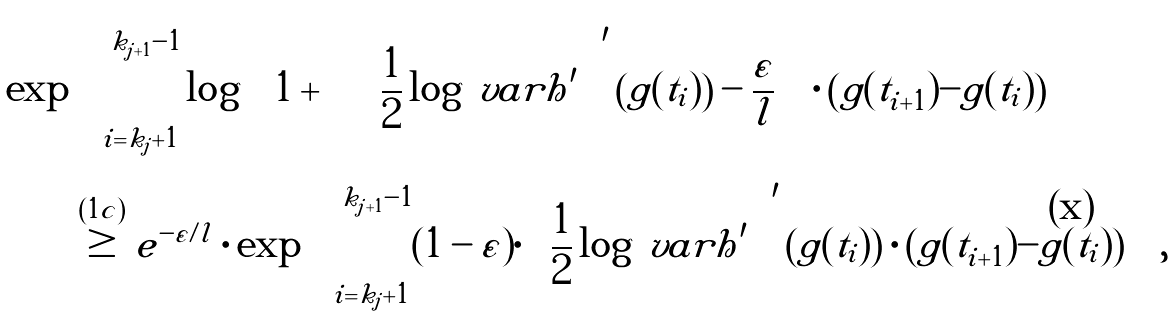<formula> <loc_0><loc_0><loc_500><loc_500>\exp & \left ( \sum ^ { k _ { j + 1 } - 1 } _ { i = k _ { j } + 1 } \log \left [ 1 + \left \{ \left ( \frac { 1 } { 2 } \log \ v a r h ^ { \prime } \right ) ^ { \prime } \left ( g ( t _ { i } ) \right ) - \frac { \varepsilon } { l } \right \} \cdot \left ( g ( t _ { i + 1 } ) - g ( t _ { i } ) \right ) \right ] \right ) \\ & \overset { ( 1 c ) } { \geq } e ^ { - \varepsilon / l } \cdot \exp \left ( \sum ^ { k _ { j + 1 } - 1 } _ { i = k _ { j } + 1 } ( 1 - \varepsilon ) \cdot \left ( \frac { 1 } { 2 } \log \ v a r h ^ { \prime } \right ) ^ { \prime } \left ( g ( t _ { i } ) \right ) \cdot \left ( g ( t _ { i + 1 } ) - g ( t _ { i } ) \right ) \right ) ,</formula> 